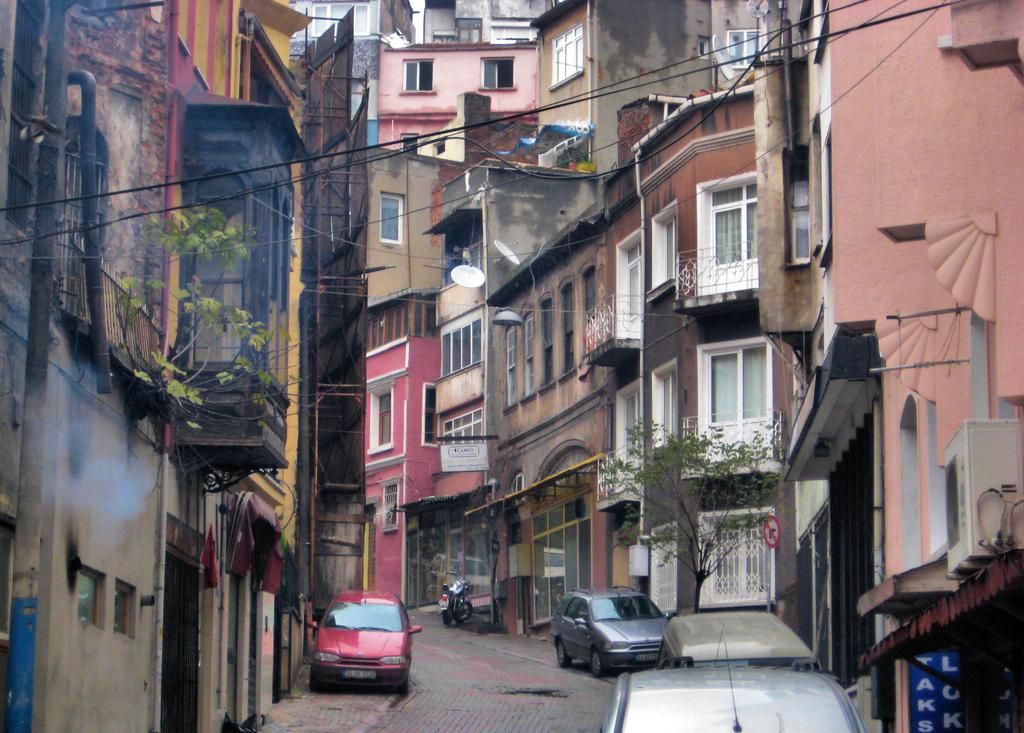What type of structures can be seen in the image? There are buildings in the image. What objects are present near the buildings? There are boards and poles with wires visible in the image. What type of vegetation is in the image? There is a tree and a plant in the image. What is happening at the bottom of the image? There are vehicles on the road at the bottom of the image. Where is the zebra located in the image? There is no zebra present in the image. What type of writing utensil can be seen on the tray in the image? There is no tray or pencil present in the image. 